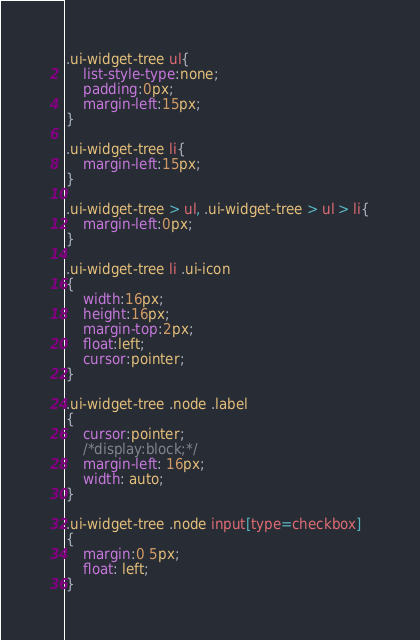Convert code to text. <code><loc_0><loc_0><loc_500><loc_500><_CSS_>.ui-widget-tree ul{
	list-style-type:none;
	padding:0px;
	margin-left:15px;
}

.ui-widget-tree li{
    margin-left:15px;
}

.ui-widget-tree > ul, .ui-widget-tree > ul > li{
	margin-left:0px;
}

.ui-widget-tree li .ui-icon
{
    width:16px;
    height:16px;
    margin-top:2px;
    float:left;
    cursor:pointer;
}

.ui-widget-tree .node .label
{
    cursor:pointer;
    /*display:block;*/
	margin-left: 16px;
    width: auto;
}

.ui-widget-tree .node input[type=checkbox]
{
    margin:0 5px;
    float: left;
}
</code> 